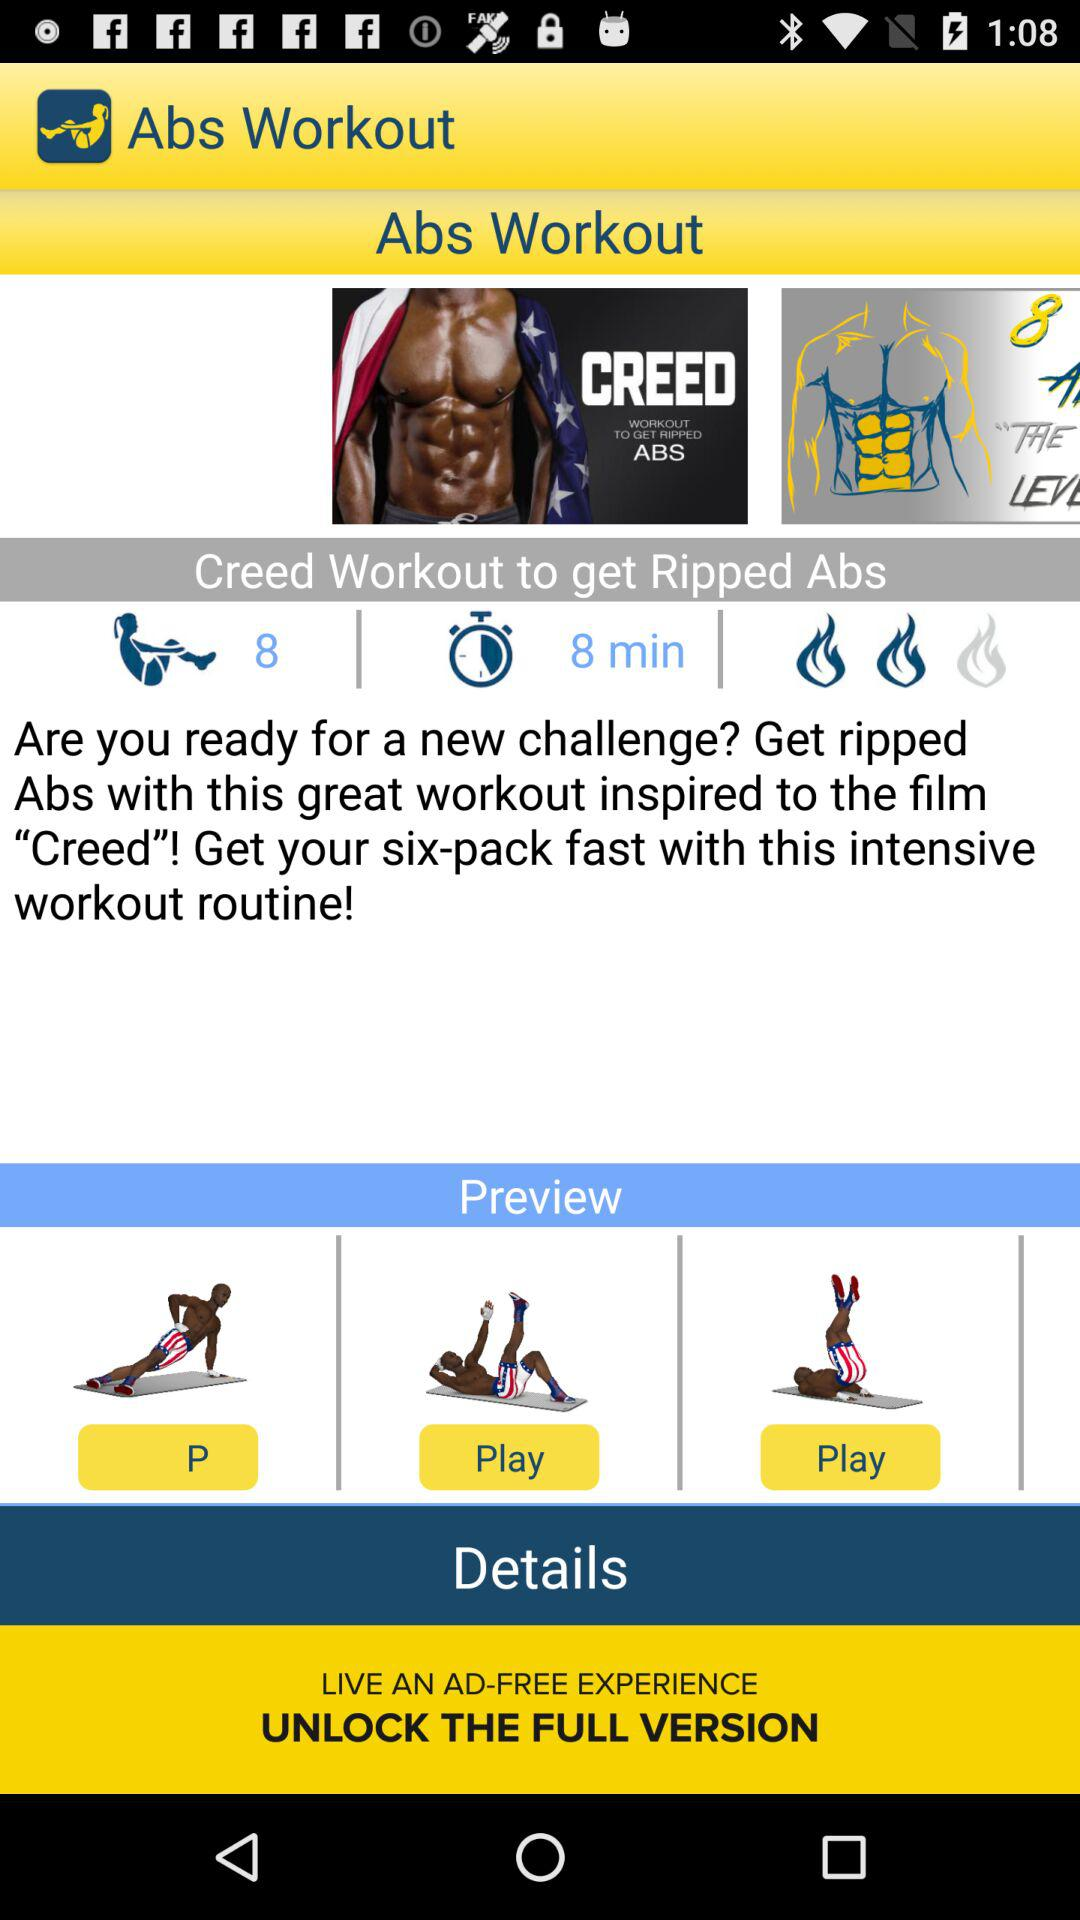What's the number of sets of exercises? The number of sets is 8. 